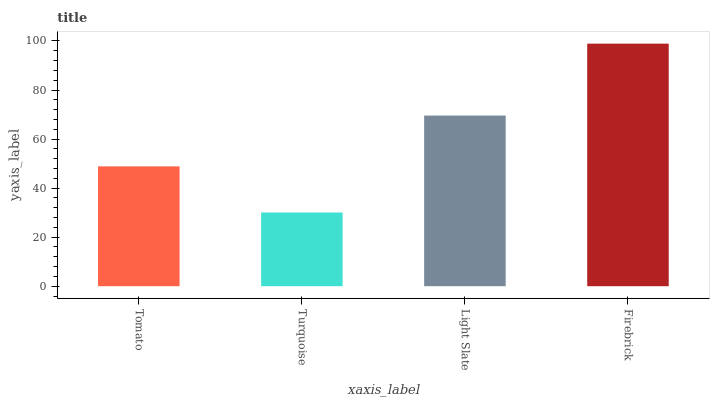Is Turquoise the minimum?
Answer yes or no. Yes. Is Firebrick the maximum?
Answer yes or no. Yes. Is Light Slate the minimum?
Answer yes or no. No. Is Light Slate the maximum?
Answer yes or no. No. Is Light Slate greater than Turquoise?
Answer yes or no. Yes. Is Turquoise less than Light Slate?
Answer yes or no. Yes. Is Turquoise greater than Light Slate?
Answer yes or no. No. Is Light Slate less than Turquoise?
Answer yes or no. No. Is Light Slate the high median?
Answer yes or no. Yes. Is Tomato the low median?
Answer yes or no. Yes. Is Tomato the high median?
Answer yes or no. No. Is Firebrick the low median?
Answer yes or no. No. 